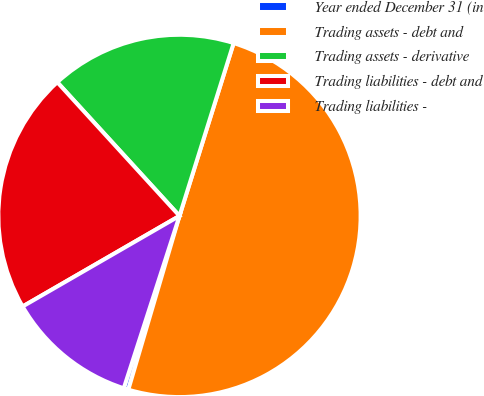<chart> <loc_0><loc_0><loc_500><loc_500><pie_chart><fcel>Year ended December 31 (in<fcel>Trading assets - debt and<fcel>Trading assets - derivative<fcel>Trading liabilities - debt and<fcel>Trading liabilities -<nl><fcel>0.42%<fcel>49.73%<fcel>16.62%<fcel>21.55%<fcel>11.69%<nl></chart> 